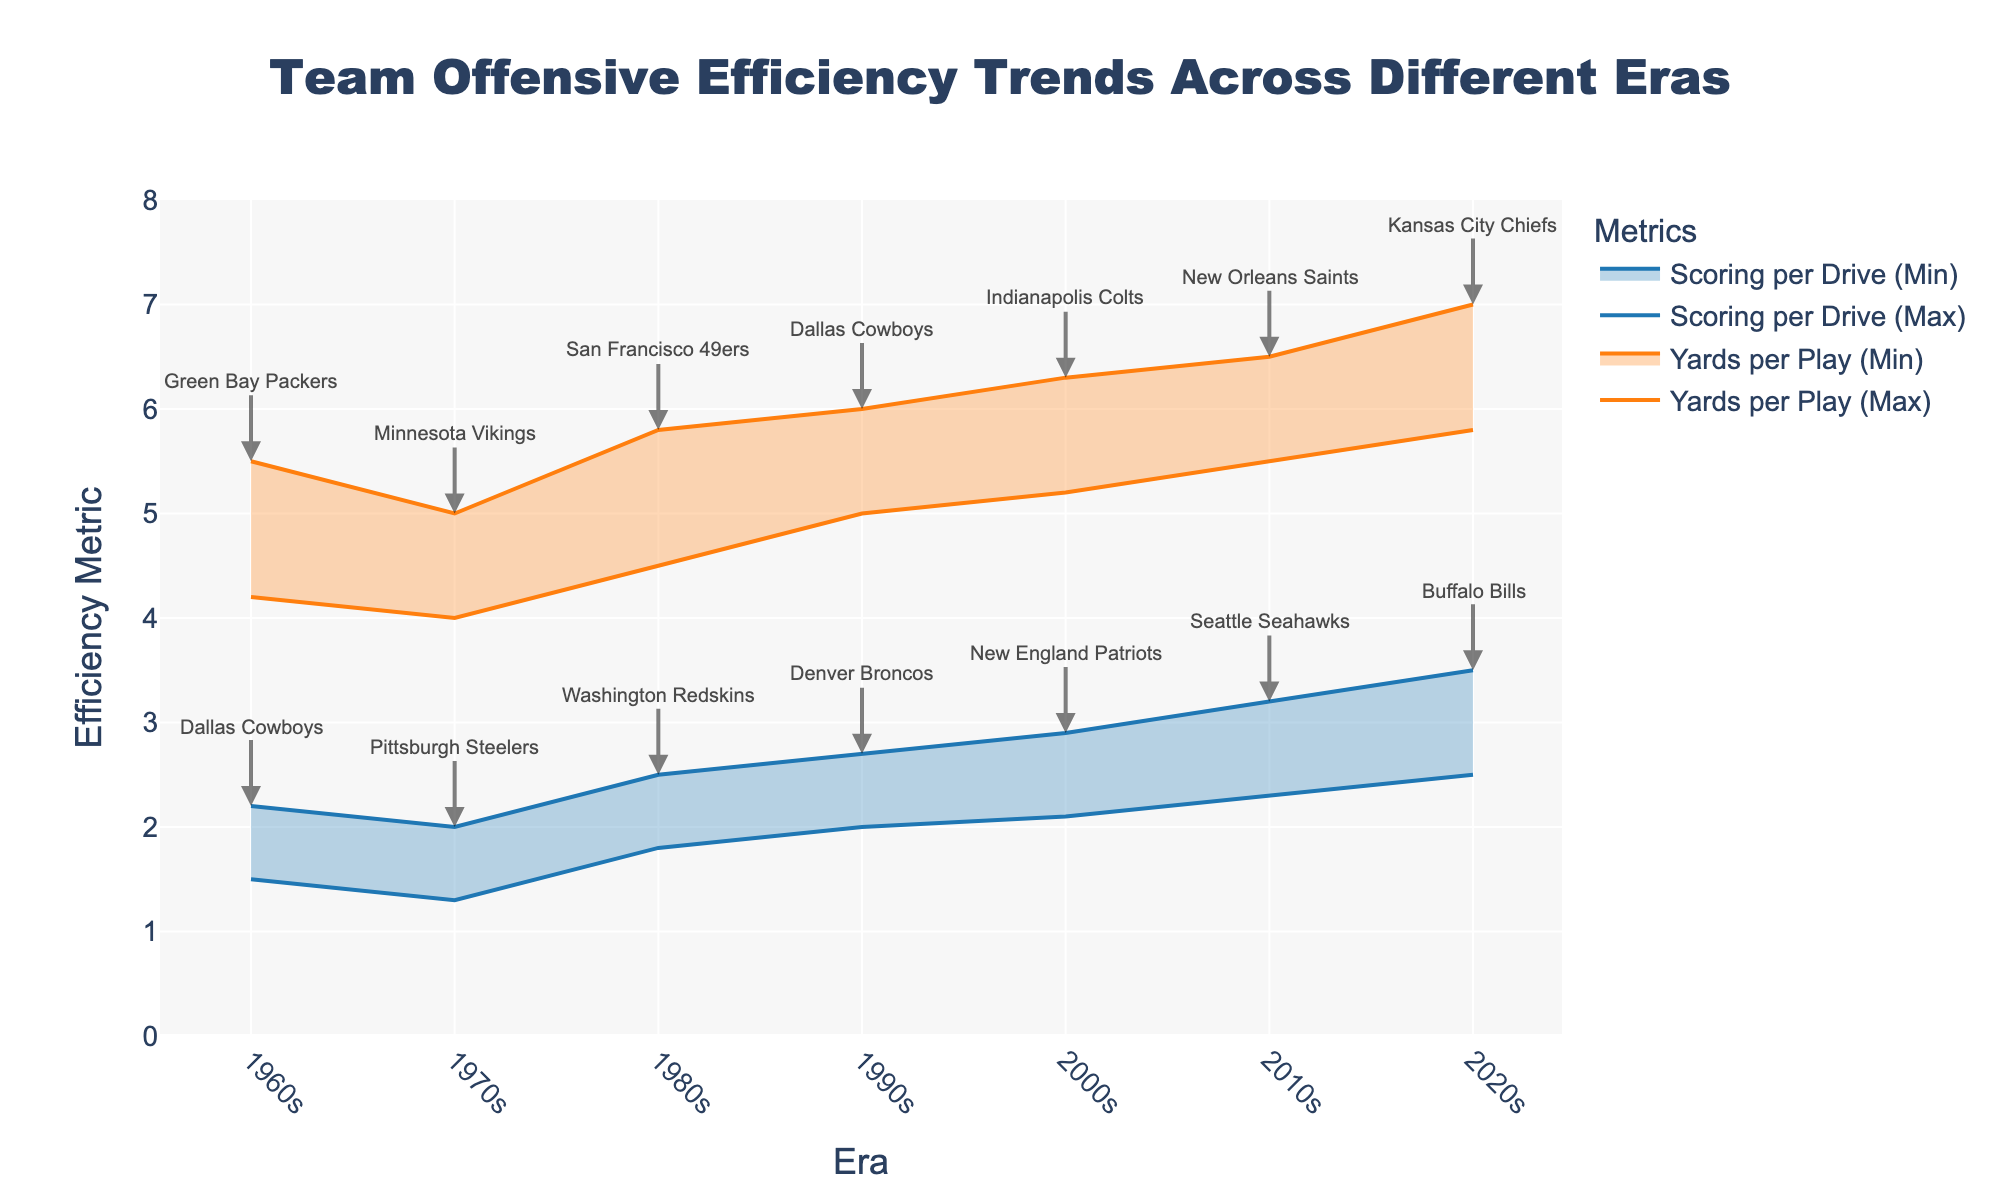How does the scoring per drive trend from the 1960s to the 2020s? To observe the trend, look at the filled area representing scoring per drive in each era. Notice the increasing range of values in each successive era, indicating improving offensive efficiency.
Answer: Increasing What's the range of yards per play for the Kansas City Chiefs in the 2020s? Identify the maximum and minimum values for the Kansas City Chiefs in the 2020s. The max value is 7.0 and the min value is 5.8, so the range is 7.0 - 5.8.
Answer: 1.2 Which team had the lowest scoring per drive metric in the 1970s? Examine the scoring per drive values for the 1970s. The lowest scoring per drive shown is for the Pittsburgh Steelers with a minimum value of 1.3.
Answer: Pittsburgh Steelers Are yards per play values higher in the 2010s compared to the 1990s? Compare the range of yards per play between the 1990s (5.0-6.0) and the 2010s (5.5-6.5). Values in the 2010s are higher.
Answer: Yes What is the difference in the maximum scoring per drive between the 1960s Dallas Cowboys and the 2000s New England Patriots? Compare the max scoring per drive values: Cowboys (2.2) versus Patriots (2.9). The difference is 2.9 - 2.2.
Answer: 0.7 Who had a higher minimum value for yards per play in the 1980s: the San Francisco 49ers or teams in the 1960s? Compare the minimum value for the 49ers in the 1980s (4.5) to teams in the 1960s (4.2 for Packers). The 49ers had a higher minimum value.
Answer: San Francisco 49ers Between which two consecutive eras did the maximum value of yards per play see the greatest increase? Compare the increase in maximum values of yards per play between consecutive eras. The greatest increase is from 2000s (6.3) to 2010s (6.5).
Answer: 2000s to 2010s What is the difference in minimum yards per play values between the 1970s and the 2020s? Compare the minimum values for the 1970s (4.0) and the 2020s (5.8). The difference is 5.8 - 4.0.
Answer: 1.8 How do the trends in scoring per drive in the 1990s compare to those in the 2000s? Examine the ranges for both eras. The 1990s range is 2.0 - 2.7 and the 2000s range is 2.1 - 2.9, indicating a slight increase.
Answer: Slightly higher in 2000s 